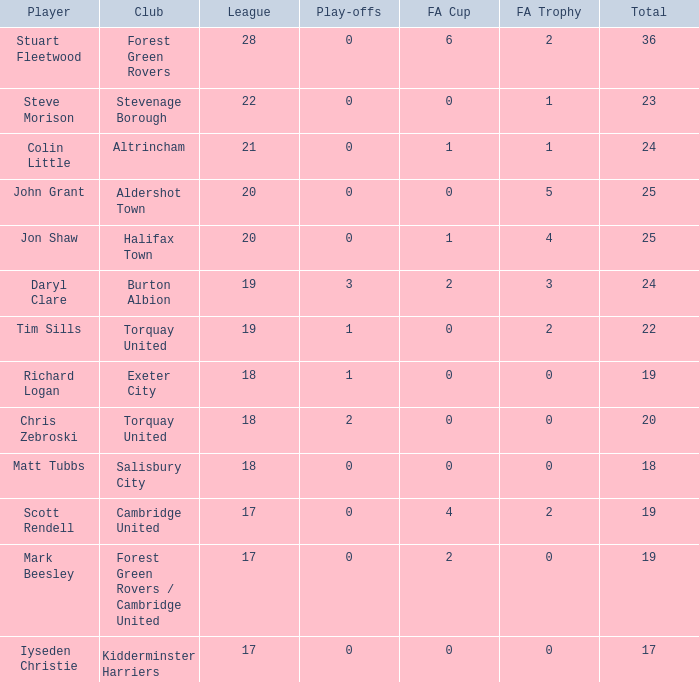What average sum had a league count of 18, richard logan as a participant, and a play-offs figure less than 1? None. 